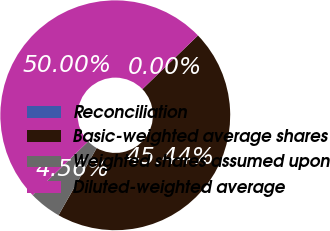<chart> <loc_0><loc_0><loc_500><loc_500><pie_chart><fcel>Reconciliation<fcel>Basic-weighted average shares<fcel>Weighted shares assumed upon<fcel>Diluted-weighted average<nl><fcel>0.0%<fcel>45.44%<fcel>4.56%<fcel>50.0%<nl></chart> 